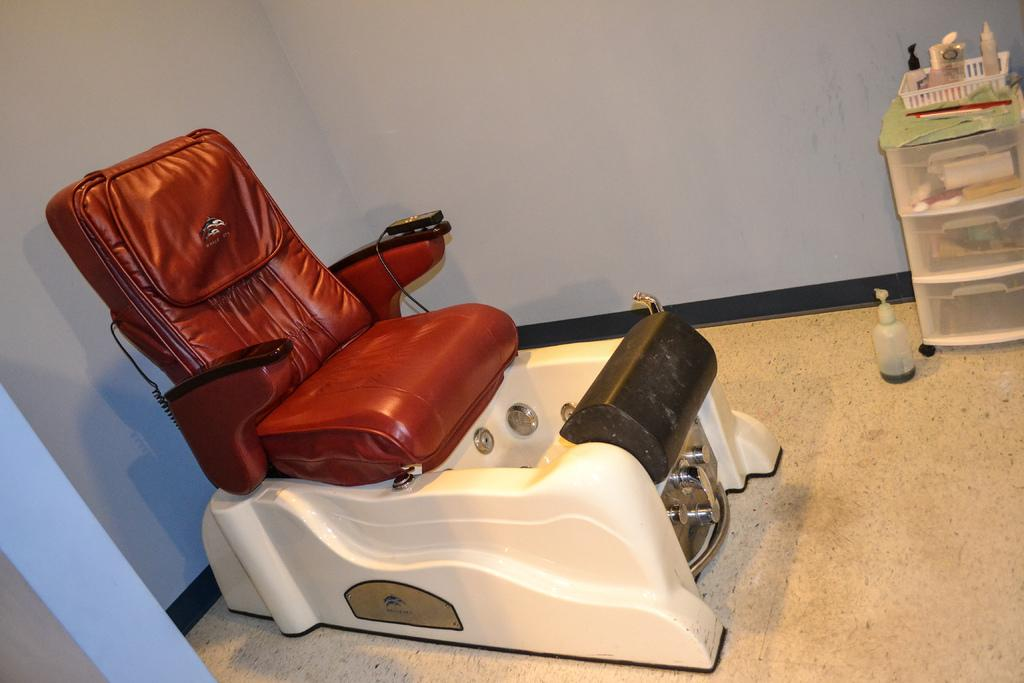What piece of furniture is located in the foreground of the image? There is a recliner in the foreground of the image. What can be seen in the background of the image? There is a small shelf, a basket, bottles, and a wall visible in the background of the image. What type of storage or display item is present in the background? There is a small shelf in the background of the image. What might be used to hold or store items in the image? The basket and shelf in the background can be used to hold or store items. What emotion is the recliner feeling in the image? The recliner is an inanimate object and does not have emotions. 